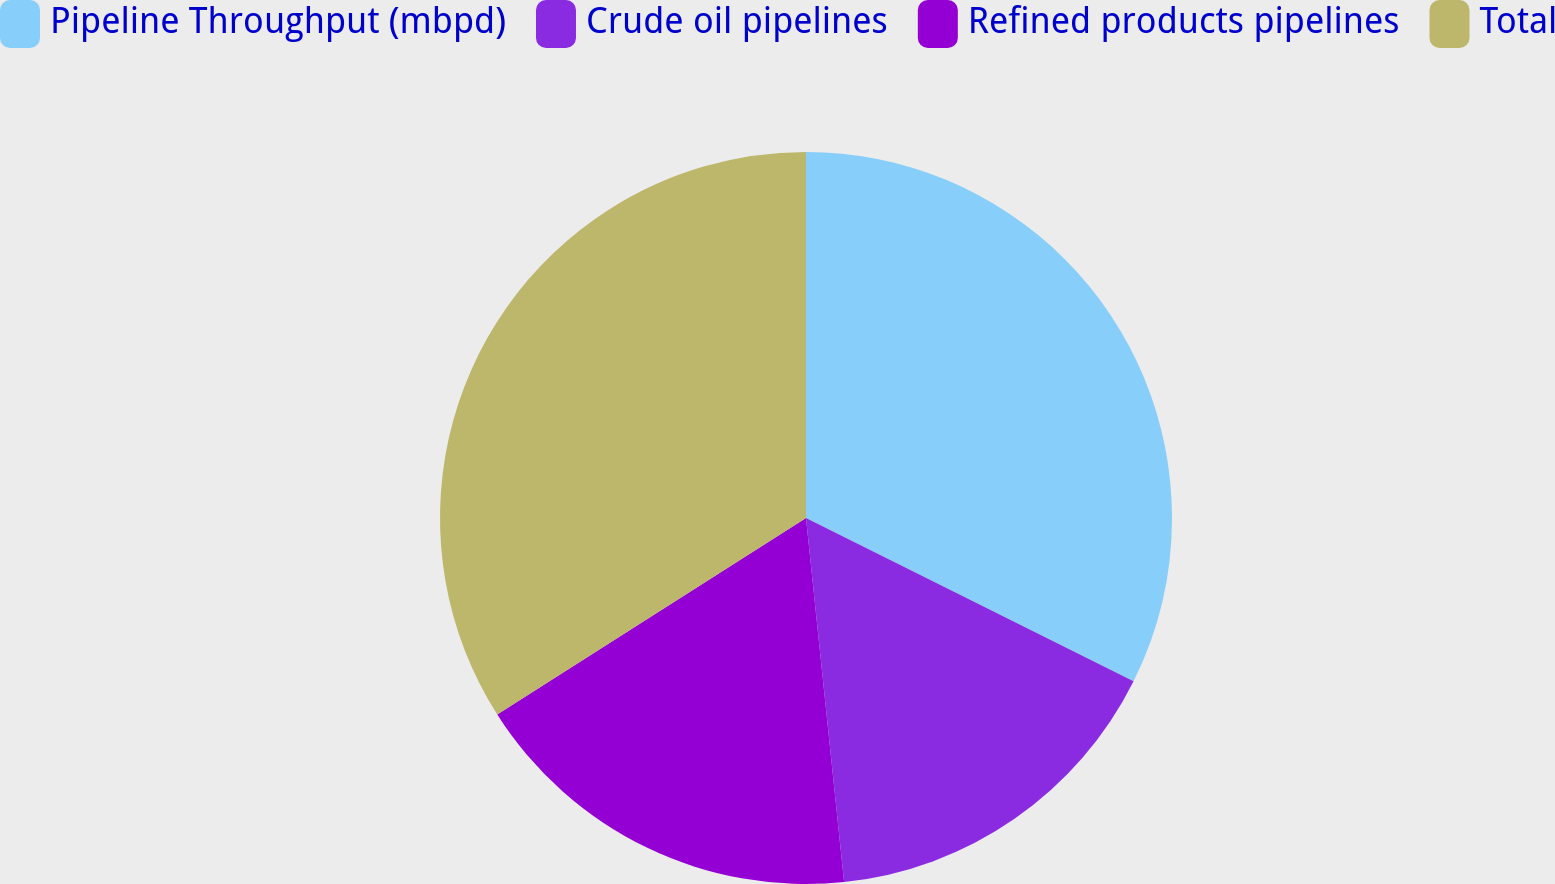Convert chart. <chart><loc_0><loc_0><loc_500><loc_500><pie_chart><fcel>Pipeline Throughput (mbpd)<fcel>Crude oil pipelines<fcel>Refined products pipelines<fcel>Total<nl><fcel>32.36%<fcel>15.98%<fcel>17.64%<fcel>34.02%<nl></chart> 